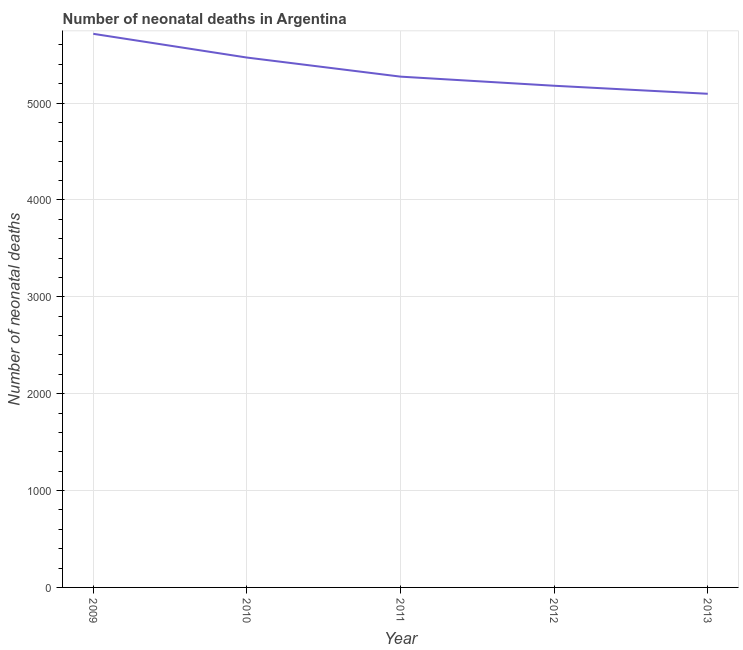What is the number of neonatal deaths in 2013?
Ensure brevity in your answer.  5096. Across all years, what is the maximum number of neonatal deaths?
Offer a very short reply. 5715. Across all years, what is the minimum number of neonatal deaths?
Your response must be concise. 5096. In which year was the number of neonatal deaths maximum?
Offer a very short reply. 2009. What is the sum of the number of neonatal deaths?
Ensure brevity in your answer.  2.67e+04. What is the difference between the number of neonatal deaths in 2010 and 2012?
Make the answer very short. 291. What is the average number of neonatal deaths per year?
Give a very brief answer. 5346.6. What is the median number of neonatal deaths?
Offer a very short reply. 5273. In how many years, is the number of neonatal deaths greater than 800 ?
Make the answer very short. 5. What is the ratio of the number of neonatal deaths in 2010 to that in 2012?
Keep it short and to the point. 1.06. Is the number of neonatal deaths in 2012 less than that in 2013?
Ensure brevity in your answer.  No. Is the difference between the number of neonatal deaths in 2009 and 2013 greater than the difference between any two years?
Provide a short and direct response. Yes. What is the difference between the highest and the second highest number of neonatal deaths?
Make the answer very short. 245. Is the sum of the number of neonatal deaths in 2009 and 2013 greater than the maximum number of neonatal deaths across all years?
Give a very brief answer. Yes. What is the difference between the highest and the lowest number of neonatal deaths?
Offer a very short reply. 619. In how many years, is the number of neonatal deaths greater than the average number of neonatal deaths taken over all years?
Offer a terse response. 2. Does the number of neonatal deaths monotonically increase over the years?
Keep it short and to the point. No. How many lines are there?
Provide a succinct answer. 1. What is the difference between two consecutive major ticks on the Y-axis?
Your response must be concise. 1000. Are the values on the major ticks of Y-axis written in scientific E-notation?
Provide a succinct answer. No. What is the title of the graph?
Your response must be concise. Number of neonatal deaths in Argentina. What is the label or title of the X-axis?
Your response must be concise. Year. What is the label or title of the Y-axis?
Provide a succinct answer. Number of neonatal deaths. What is the Number of neonatal deaths of 2009?
Ensure brevity in your answer.  5715. What is the Number of neonatal deaths of 2010?
Provide a short and direct response. 5470. What is the Number of neonatal deaths in 2011?
Provide a short and direct response. 5273. What is the Number of neonatal deaths in 2012?
Keep it short and to the point. 5179. What is the Number of neonatal deaths of 2013?
Ensure brevity in your answer.  5096. What is the difference between the Number of neonatal deaths in 2009 and 2010?
Give a very brief answer. 245. What is the difference between the Number of neonatal deaths in 2009 and 2011?
Keep it short and to the point. 442. What is the difference between the Number of neonatal deaths in 2009 and 2012?
Offer a very short reply. 536. What is the difference between the Number of neonatal deaths in 2009 and 2013?
Offer a very short reply. 619. What is the difference between the Number of neonatal deaths in 2010 and 2011?
Your response must be concise. 197. What is the difference between the Number of neonatal deaths in 2010 and 2012?
Offer a very short reply. 291. What is the difference between the Number of neonatal deaths in 2010 and 2013?
Give a very brief answer. 374. What is the difference between the Number of neonatal deaths in 2011 and 2012?
Keep it short and to the point. 94. What is the difference between the Number of neonatal deaths in 2011 and 2013?
Offer a terse response. 177. What is the ratio of the Number of neonatal deaths in 2009 to that in 2010?
Your answer should be compact. 1.04. What is the ratio of the Number of neonatal deaths in 2009 to that in 2011?
Make the answer very short. 1.08. What is the ratio of the Number of neonatal deaths in 2009 to that in 2012?
Your answer should be compact. 1.1. What is the ratio of the Number of neonatal deaths in 2009 to that in 2013?
Offer a very short reply. 1.12. What is the ratio of the Number of neonatal deaths in 2010 to that in 2012?
Your response must be concise. 1.06. What is the ratio of the Number of neonatal deaths in 2010 to that in 2013?
Your response must be concise. 1.07. What is the ratio of the Number of neonatal deaths in 2011 to that in 2012?
Offer a terse response. 1.02. What is the ratio of the Number of neonatal deaths in 2011 to that in 2013?
Provide a short and direct response. 1.03. What is the ratio of the Number of neonatal deaths in 2012 to that in 2013?
Keep it short and to the point. 1.02. 